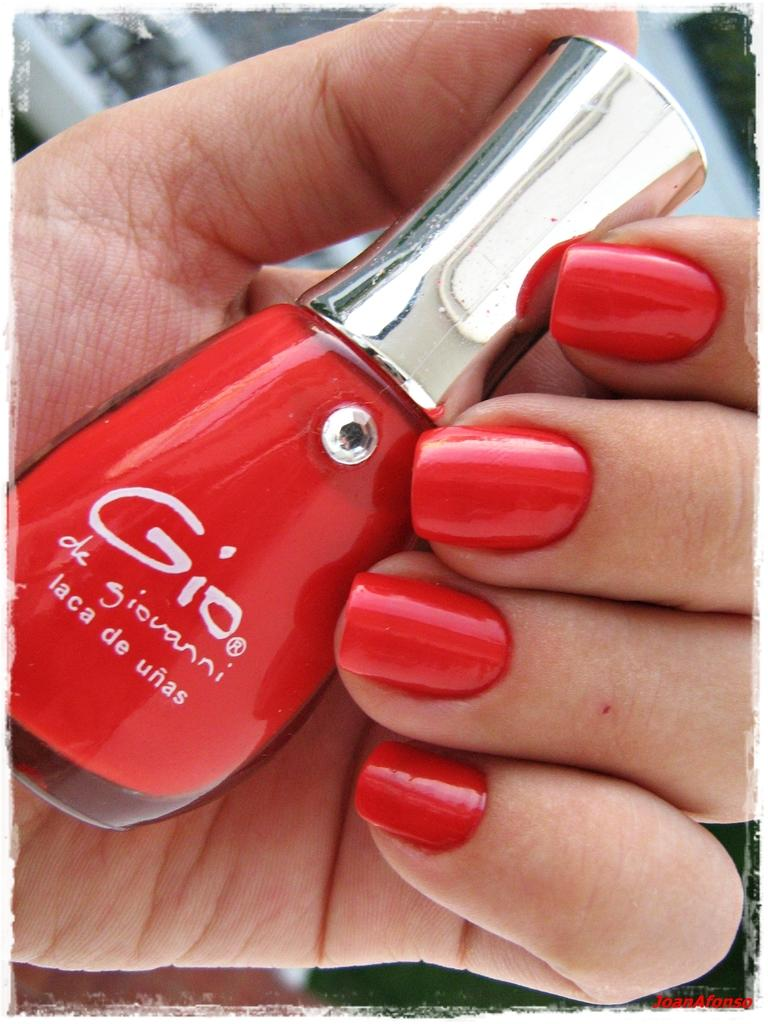What object is being held by a person in the image? There is a nail polish bottle in the image, and it is being held by a person. Can you describe the background of the image? The background of the image is blurry. What type of plants can be seen growing on the current in the image? There is no current or plants present in the image; it features a nail polish bottle being held by a person with a blurry background. 